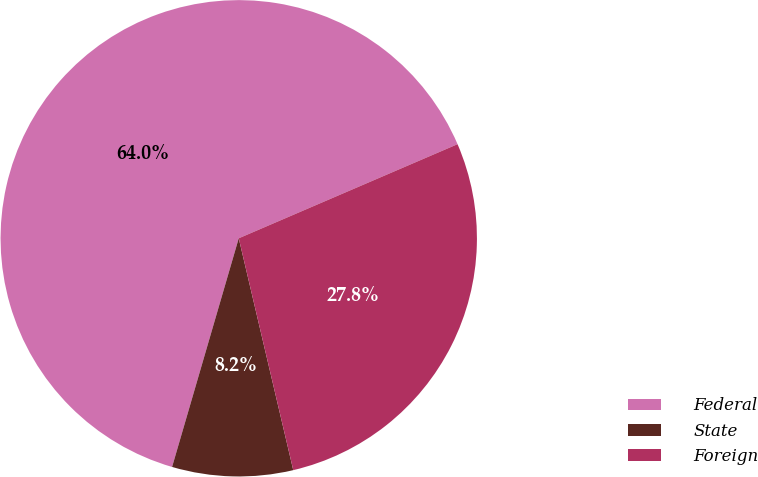Convert chart. <chart><loc_0><loc_0><loc_500><loc_500><pie_chart><fcel>Federal<fcel>State<fcel>Foreign<nl><fcel>64.02%<fcel>8.19%<fcel>27.79%<nl></chart> 